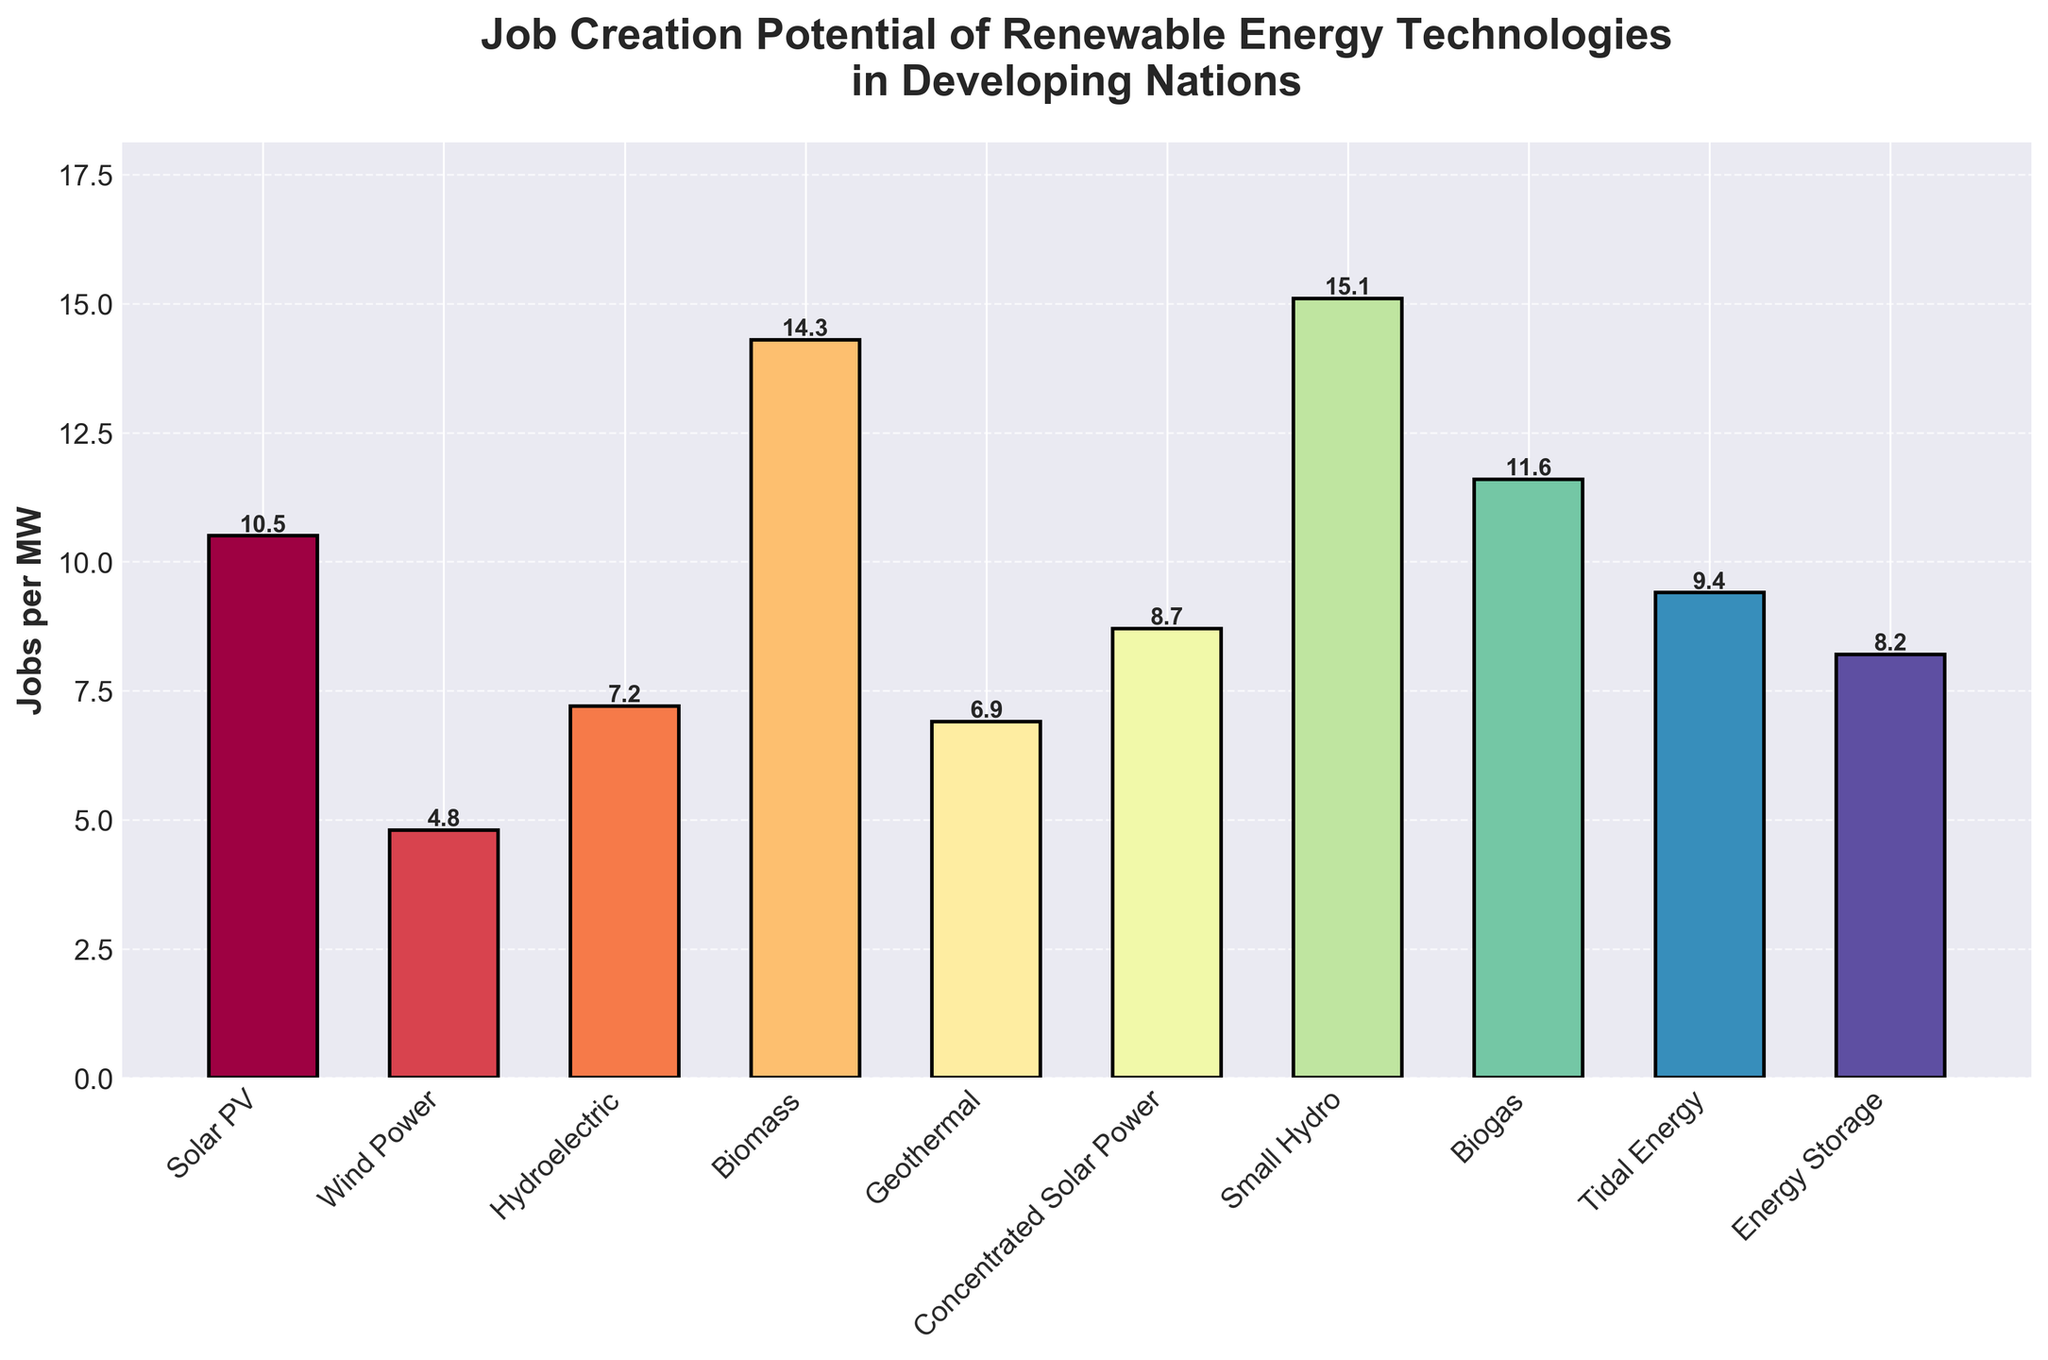Which technology creates the highest number of jobs per MW? The bar chart shows the job creation potential for different renewable technologies. The highest bar corresponds to Small Hydro.
Answer: Small Hydro Which technology creates the lowest number of jobs per MW? The bar chart shows the job creation potential for different renewable technologies. The lowest bar corresponds to Wind Power.
Answer: Wind Power How many more jobs per MW does Small Hydro create compared to Wind Power? Small Hydro creates 15.1 jobs per MW, and Wind Power creates 4.8 jobs per MW. The difference is 15.1 - 4.8 = 10.3 jobs per MW.
Answer: 10.3 What is the average job creation potential across all the technologies? Sum up all the jobs per MW (10.5 + 4.8 + 7.2 + 14.3 + 6.9 + 8.7 + 15.1 + 11.6 + 9.4 + 8.2 = 96.7) and divide by the number of technologies (10). The average is 96.7 / 10 = 9.67 jobs per MW.
Answer: 9.67 Which technology has a job creation potential closest to the average job creation potential? The average job creation potential is 9.67 jobs per MW. Looking at the bars, Tidal Energy (9.4) is the closest to this average.
Answer: Tidal Energy Between Solar PV and Biomass, which creates more jobs per MW and by how much? Solar PV creates 10.5 jobs per MW, Biomass creates 14.3 jobs per MW. The difference is 14.3 - 10.5 = 3.8 jobs per MW.
Answer: Biomass, by 3.8 Which colored bar represents the highest job creation potential, and what is this color? The highest bar corresponds to Small Hydro, represented by a specific color from the Spectral colormap, but it's the primary tallest bar visible.
Answer: (Descriptor of the visible color for the Small Hydro bar) Compare the job creation potential of Geothermal and Biomass. Which one is greater, and by how many jobs per MW? Geothermal creates 6.9 jobs per MW, Biomass creates 14.3 jobs per MW. The difference is 14.3 - 6.9 = 7.4 jobs per MW.
Answer: Biomass, by 7.4 Visual comparison: Which has more job creation potential—Energy Storage or Concentrated Solar Power? By comparing the height of the bars, Energy Storage creates 8.2 jobs per MW, while Concentrated Solar Power creates 8.7 jobs per MW. Hence, Concentrated Solar Power has more job creation potential.
Answer: Concentrated Solar Power 